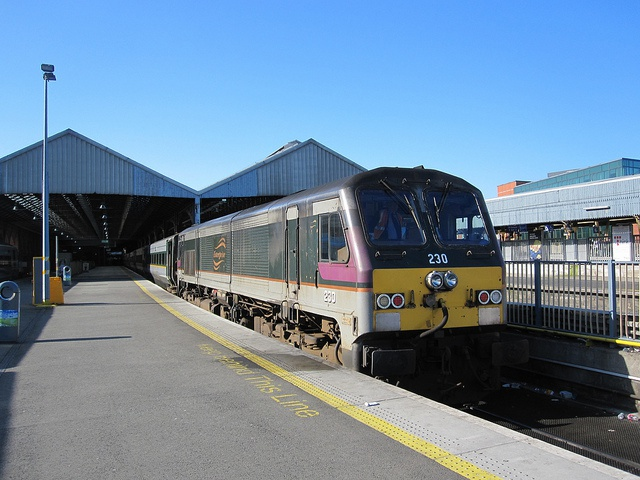Describe the objects in this image and their specific colors. I can see train in lightblue, black, gray, darkgray, and lightgray tones and people in black, navy, darkblue, and lightblue tones in this image. 